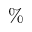Convert formula to latex. <formula><loc_0><loc_0><loc_500><loc_500>\%</formula> 